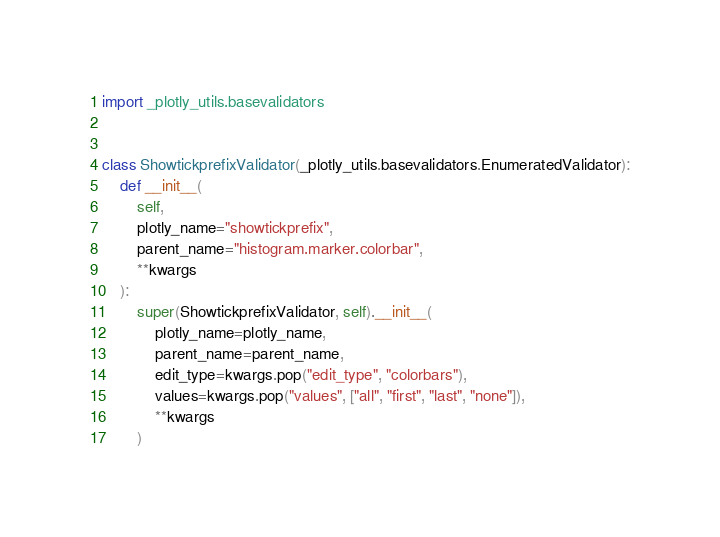Convert code to text. <code><loc_0><loc_0><loc_500><loc_500><_Python_>import _plotly_utils.basevalidators


class ShowtickprefixValidator(_plotly_utils.basevalidators.EnumeratedValidator):
    def __init__(
        self,
        plotly_name="showtickprefix",
        parent_name="histogram.marker.colorbar",
        **kwargs
    ):
        super(ShowtickprefixValidator, self).__init__(
            plotly_name=plotly_name,
            parent_name=parent_name,
            edit_type=kwargs.pop("edit_type", "colorbars"),
            values=kwargs.pop("values", ["all", "first", "last", "none"]),
            **kwargs
        )
</code> 